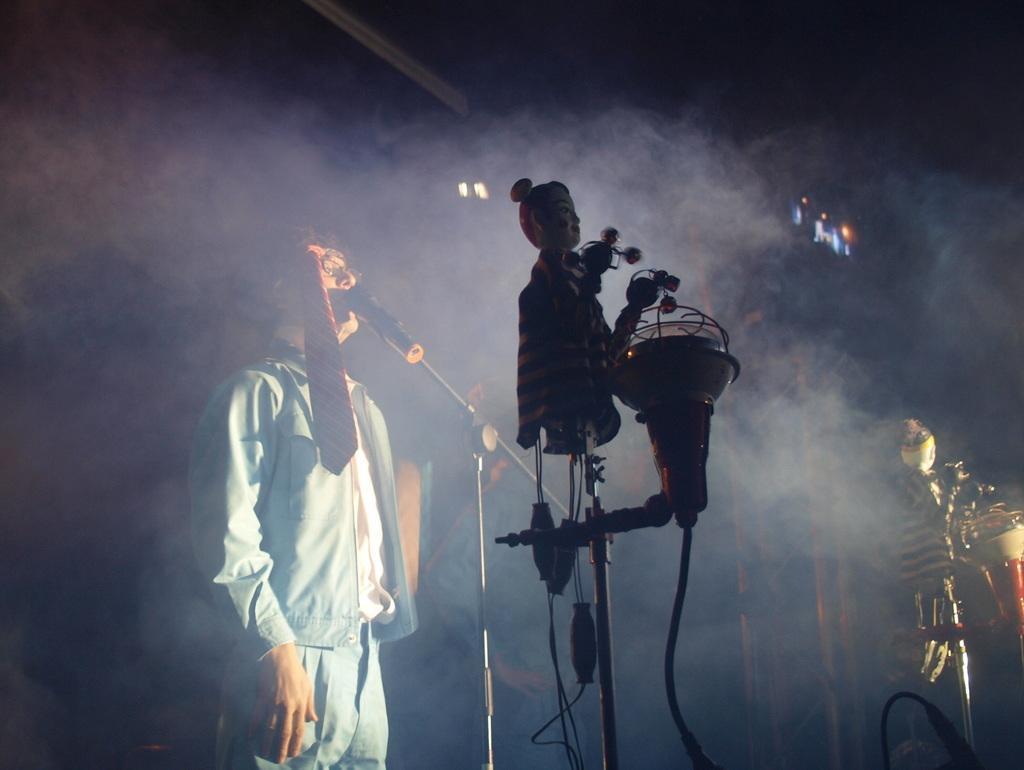Could you give a brief overview of what you see in this image? In the image there is a man in sea green dress singing on mic with music instruments behind him and smoke all over the place. 